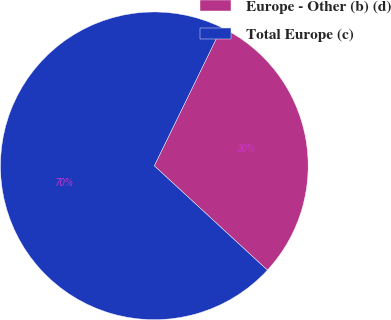Convert chart. <chart><loc_0><loc_0><loc_500><loc_500><pie_chart><fcel>Europe - Other (b) (d)<fcel>Total Europe (c)<nl><fcel>29.64%<fcel>70.36%<nl></chart> 